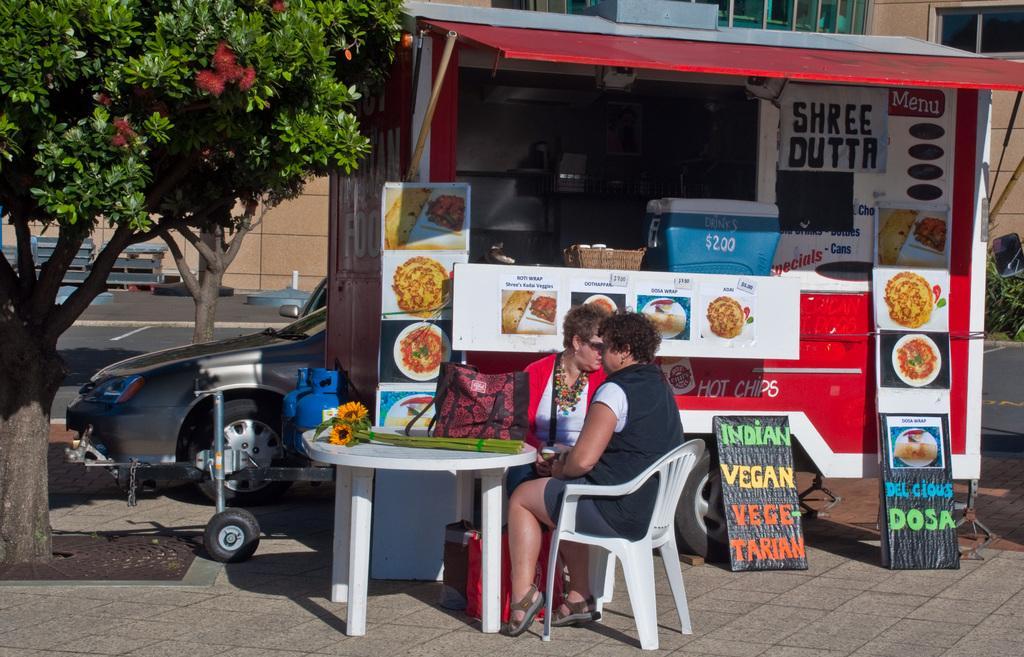How would you summarize this image in a sentence or two? In this picture we can see two persons are sitting on the chairs. This is table. On the table there are flowers, and a bag. Here we can see a stall and these are the boards. There are trees and this is a vehicle. On the background there is a building. 